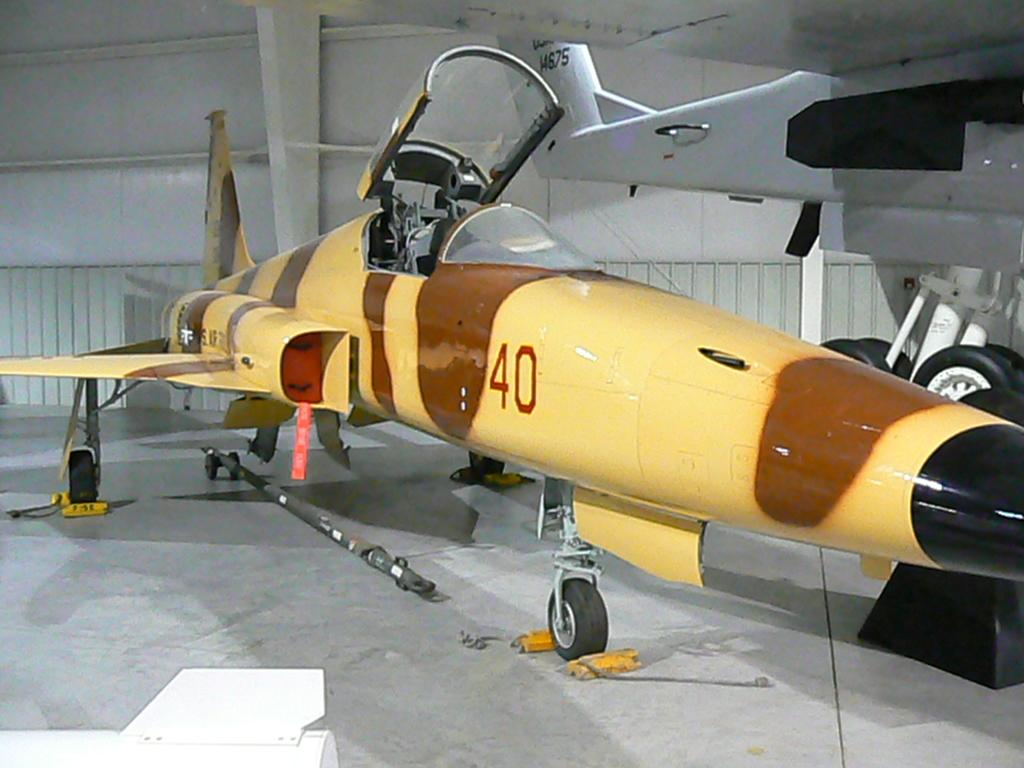<image>
Give a short and clear explanation of the subsequent image. Brown and yellow airplane with the numbe 40 on it's side. 